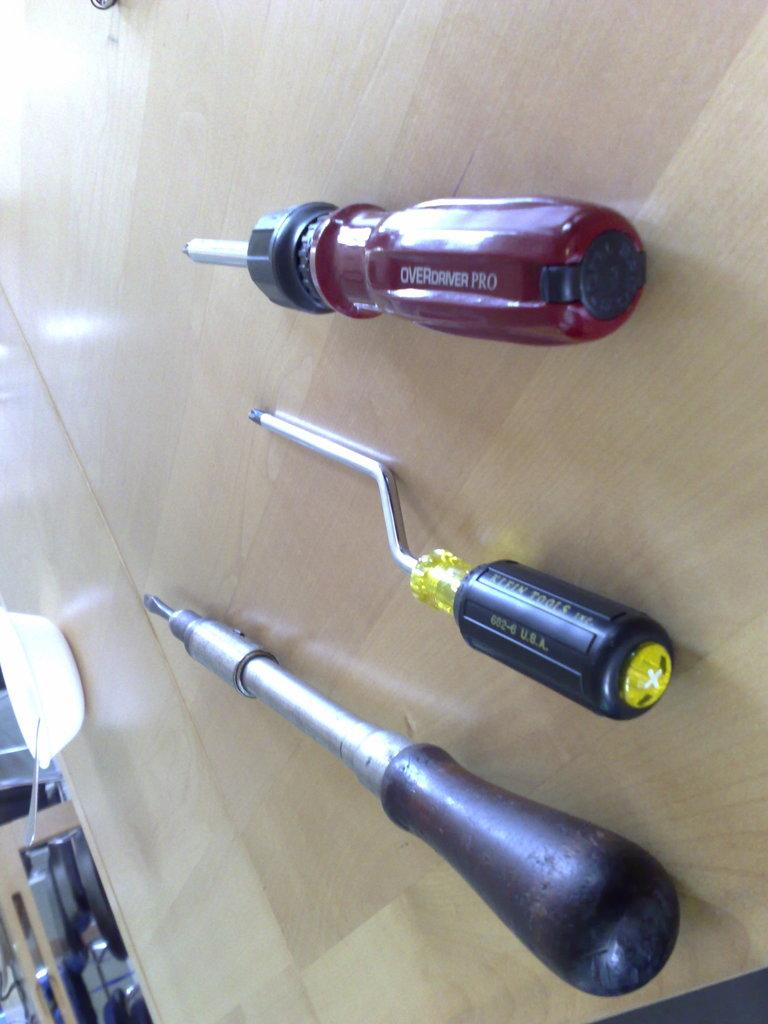What type of furniture is present in the image? There is a table in the image. What can be found on the table? There are objects on the table, which include equipment. What is used for eating or serving food on the table? There is a bowl with a spoon on the table. Where are additional objects located in the image? There are objects in the bottom left side of the image. What type of pipe is being used by the representative in the image? There is no representative or pipe present in the image. 